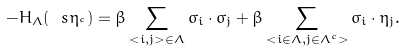<formula> <loc_0><loc_0><loc_500><loc_500>- H _ { \Lambda } ( \ s _ { \L } \eta _ { \L ^ { c } } ) = \beta \sum _ { < i , j > \in \Lambda } \sigma _ { i } \cdot \sigma _ { j } + \beta \sum _ { < i \in \Lambda , j \in \Lambda ^ { c } > } \sigma _ { i } \cdot \eta _ { j } .</formula> 